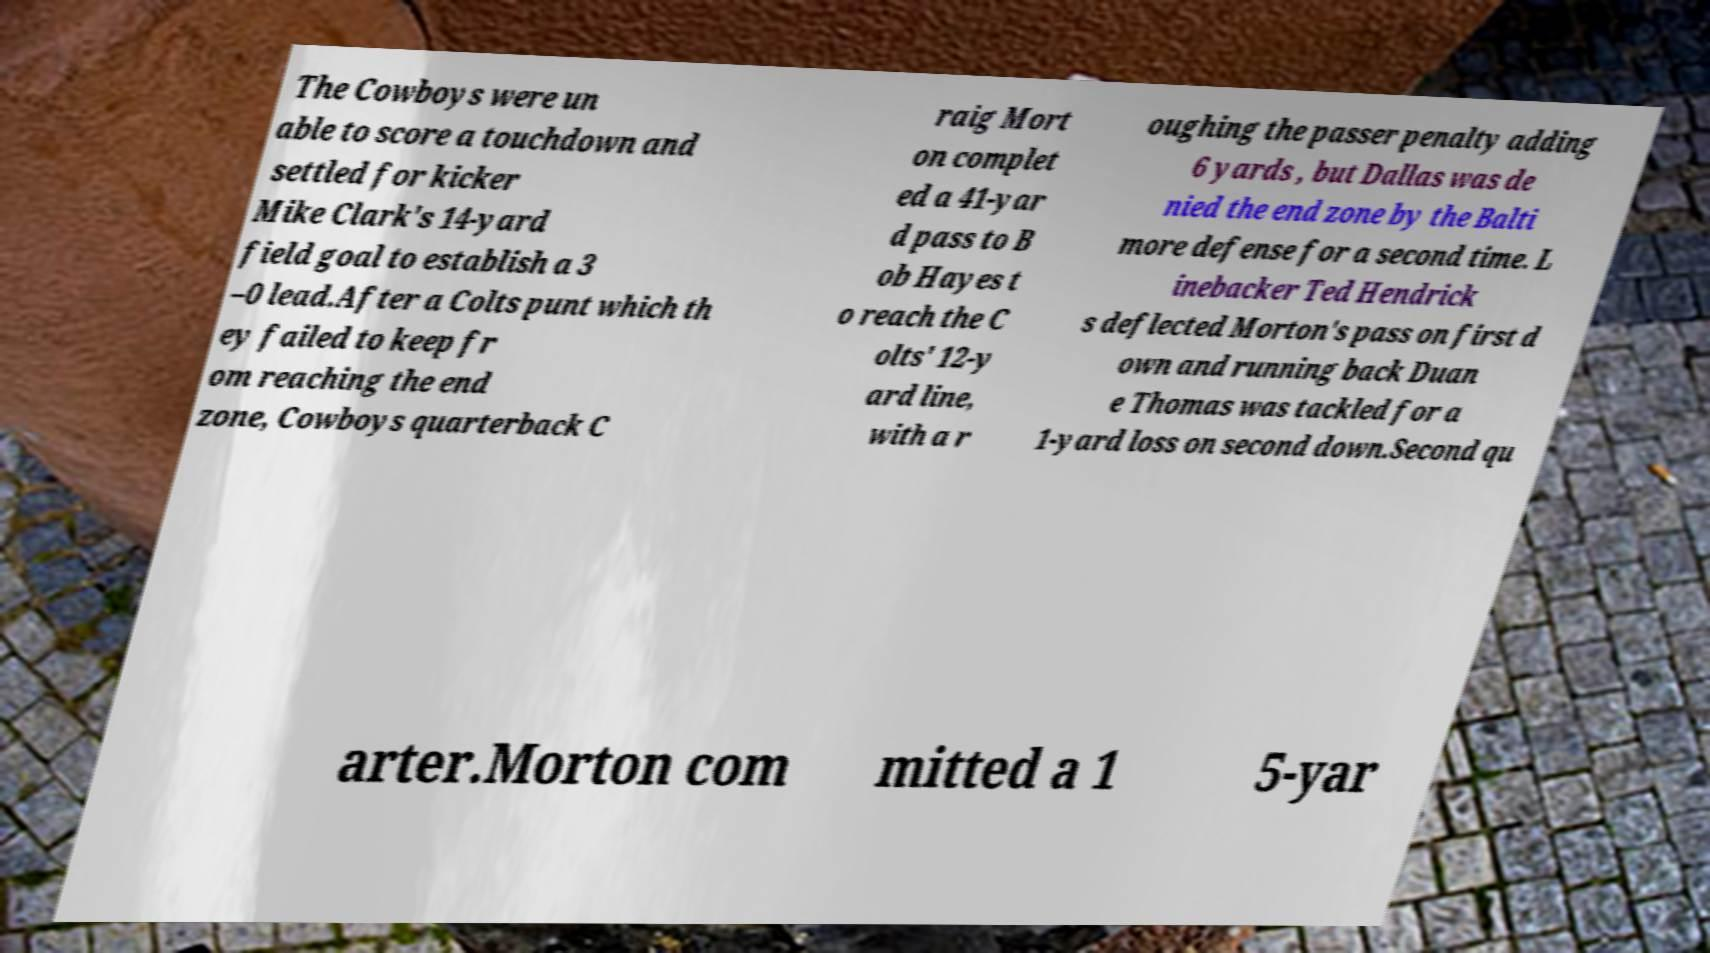Can you read and provide the text displayed in the image?This photo seems to have some interesting text. Can you extract and type it out for me? The Cowboys were un able to score a touchdown and settled for kicker Mike Clark's 14-yard field goal to establish a 3 –0 lead.After a Colts punt which th ey failed to keep fr om reaching the end zone, Cowboys quarterback C raig Mort on complet ed a 41-yar d pass to B ob Hayes t o reach the C olts' 12-y ard line, with a r oughing the passer penalty adding 6 yards , but Dallas was de nied the end zone by the Balti more defense for a second time. L inebacker Ted Hendrick s deflected Morton's pass on first d own and running back Duan e Thomas was tackled for a 1-yard loss on second down.Second qu arter.Morton com mitted a 1 5-yar 